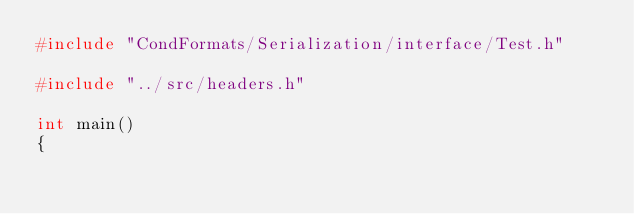Convert code to text. <code><loc_0><loc_0><loc_500><loc_500><_C++_>#include "CondFormats/Serialization/interface/Test.h"

#include "../src/headers.h"

int main()
{</code> 